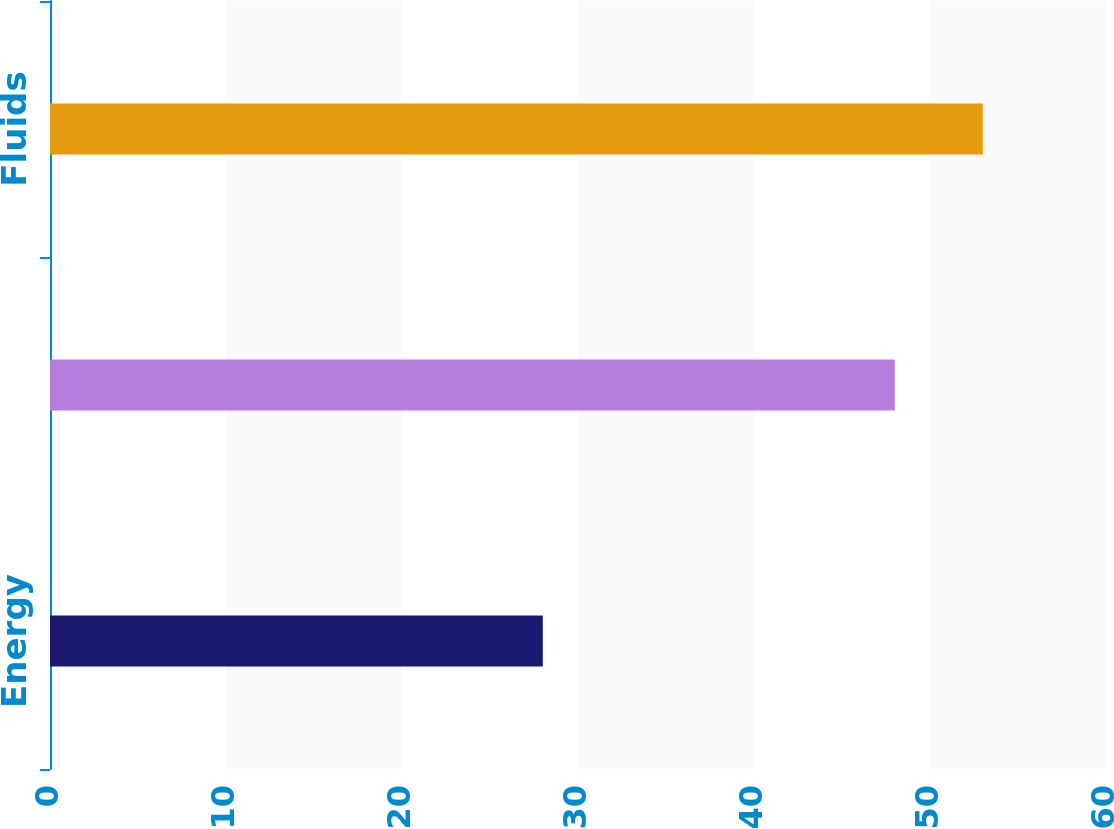Convert chart to OTSL. <chart><loc_0><loc_0><loc_500><loc_500><bar_chart><fcel>Energy<fcel>Engineered Systems<fcel>Fluids<nl><fcel>28<fcel>48<fcel>53<nl></chart> 